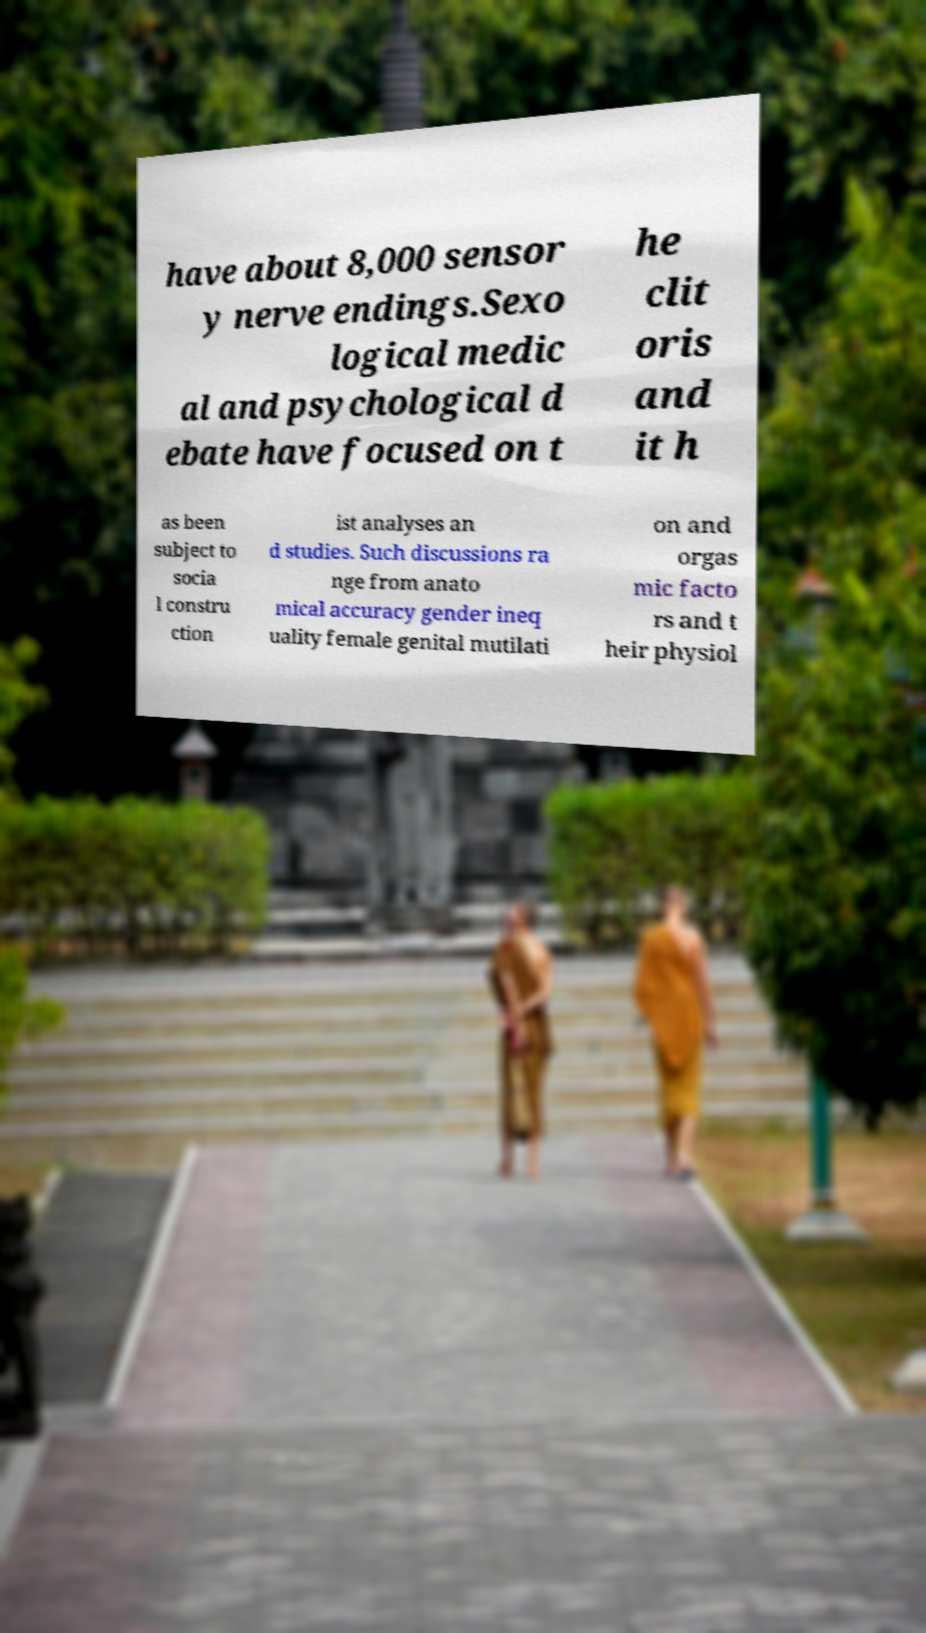Can you read and provide the text displayed in the image?This photo seems to have some interesting text. Can you extract and type it out for me? have about 8,000 sensor y nerve endings.Sexo logical medic al and psychological d ebate have focused on t he clit oris and it h as been subject to socia l constru ction ist analyses an d studies. Such discussions ra nge from anato mical accuracy gender ineq uality female genital mutilati on and orgas mic facto rs and t heir physiol 